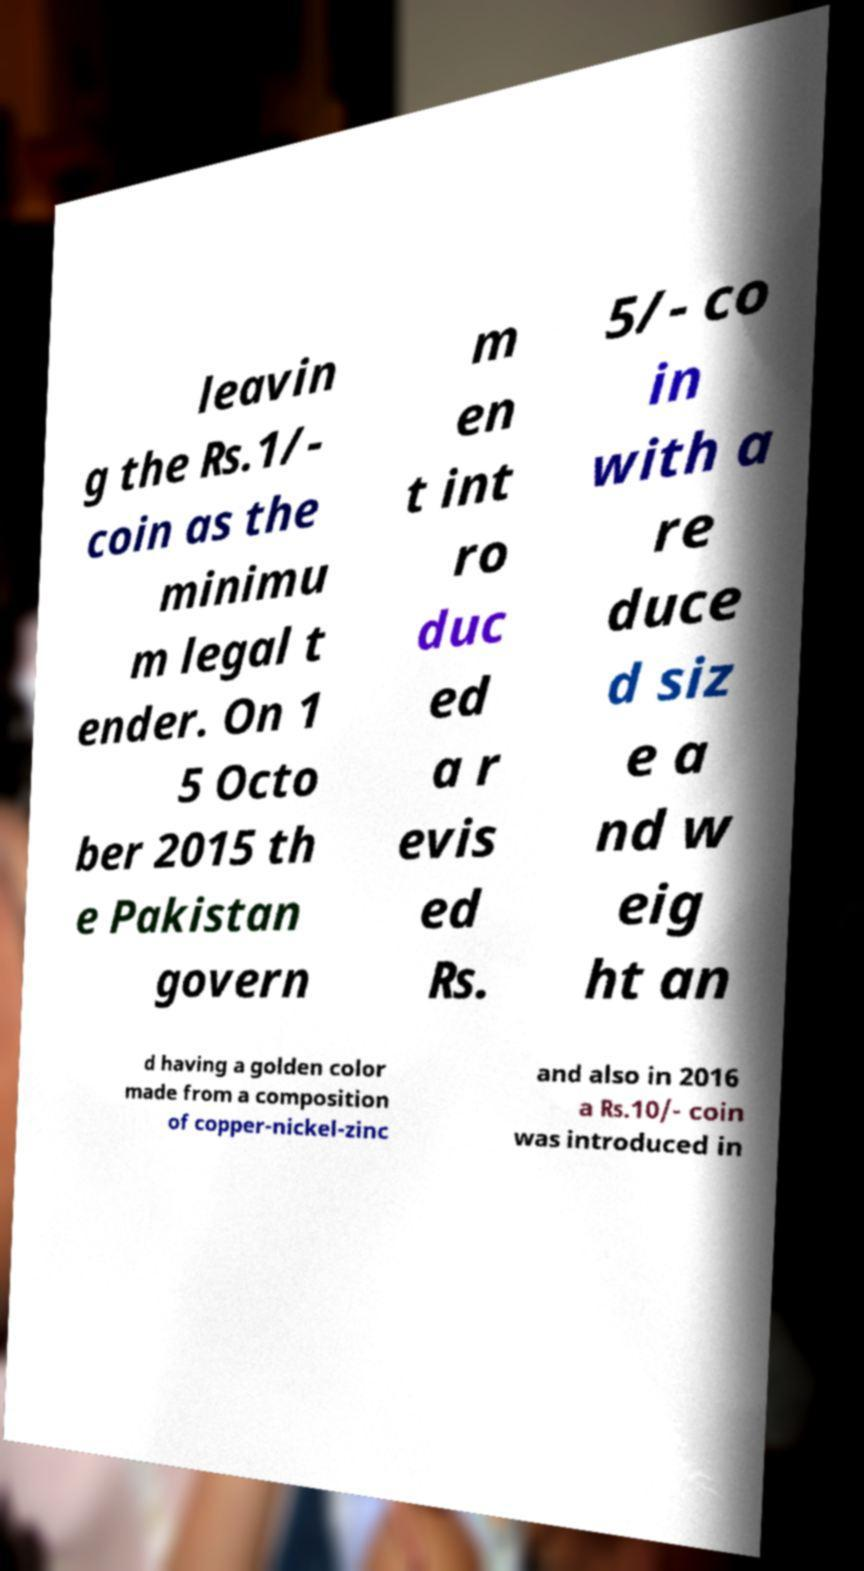What messages or text are displayed in this image? I need them in a readable, typed format. leavin g the ₨.1/- coin as the minimu m legal t ender. On 1 5 Octo ber 2015 th e Pakistan govern m en t int ro duc ed a r evis ed ₨. 5/- co in with a re duce d siz e a nd w eig ht an d having a golden color made from a composition of copper-nickel-zinc and also in 2016 a ₨.10/- coin was introduced in 